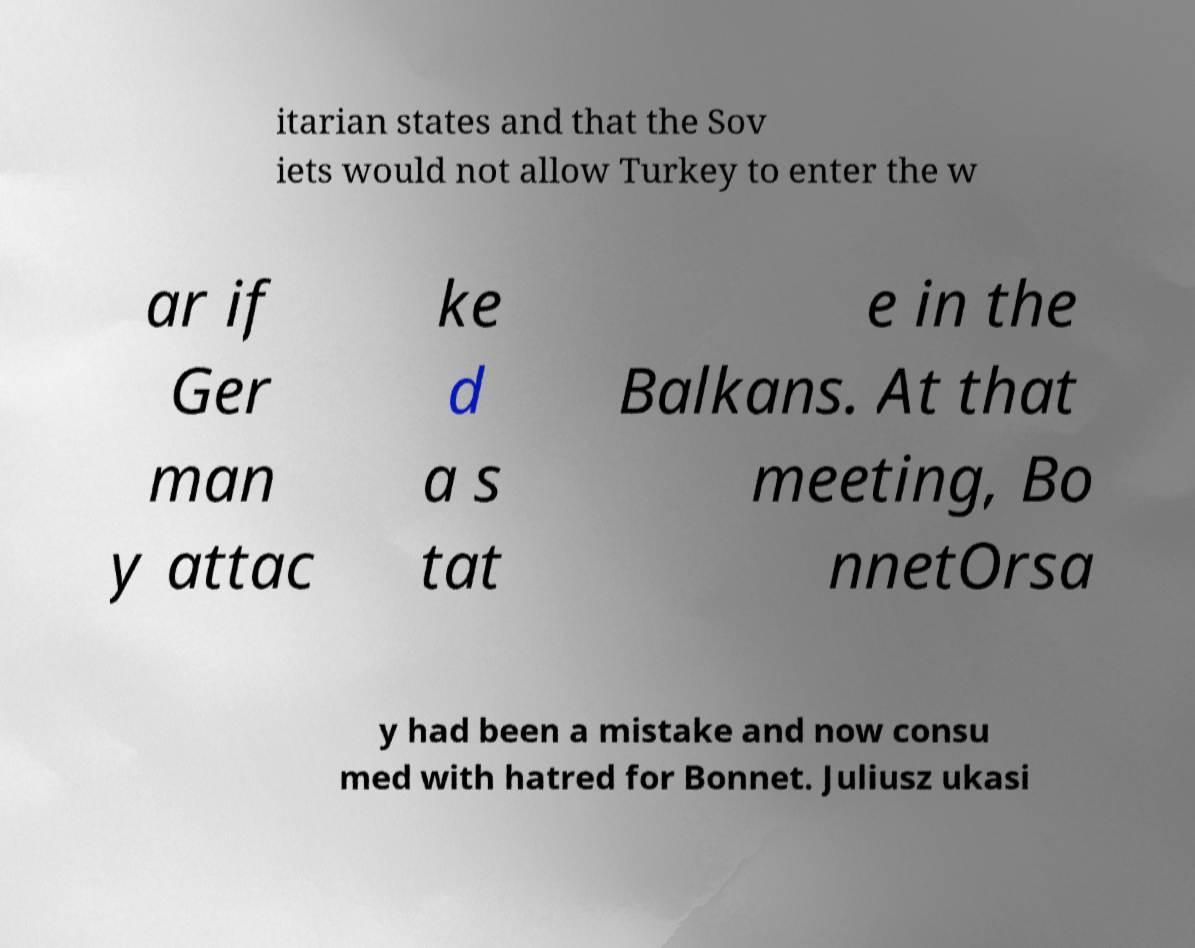Please read and relay the text visible in this image. What does it say? itarian states and that the Sov iets would not allow Turkey to enter the w ar if Ger man y attac ke d a s tat e in the Balkans. At that meeting, Bo nnetOrsa y had been a mistake and now consu med with hatred for Bonnet. Juliusz ukasi 